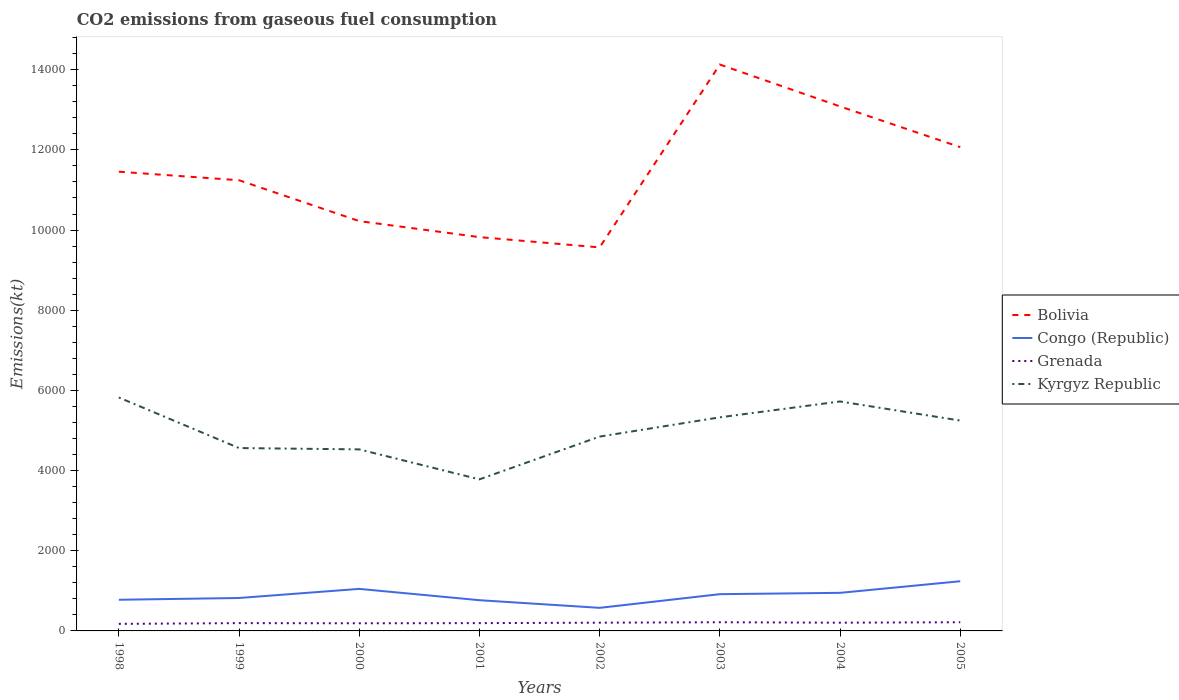How many different coloured lines are there?
Offer a terse response. 4. Does the line corresponding to Congo (Republic) intersect with the line corresponding to Kyrgyz Republic?
Your response must be concise. No. Is the number of lines equal to the number of legend labels?
Provide a short and direct response. Yes. Across all years, what is the maximum amount of CO2 emitted in Grenada?
Give a very brief answer. 176.02. In which year was the amount of CO2 emitted in Congo (Republic) maximum?
Keep it short and to the point. 2002. What is the difference between the highest and the second highest amount of CO2 emitted in Congo (Republic)?
Your response must be concise. 663.73. Is the amount of CO2 emitted in Congo (Republic) strictly greater than the amount of CO2 emitted in Kyrgyz Republic over the years?
Provide a short and direct response. Yes. What is the difference between two consecutive major ticks on the Y-axis?
Your answer should be compact. 2000. Are the values on the major ticks of Y-axis written in scientific E-notation?
Keep it short and to the point. No. How many legend labels are there?
Give a very brief answer. 4. What is the title of the graph?
Offer a terse response. CO2 emissions from gaseous fuel consumption. What is the label or title of the X-axis?
Your answer should be compact. Years. What is the label or title of the Y-axis?
Your response must be concise. Emissions(kt). What is the Emissions(kt) of Bolivia in 1998?
Ensure brevity in your answer.  1.15e+04. What is the Emissions(kt) in Congo (Republic) in 1998?
Offer a terse response. 777.4. What is the Emissions(kt) in Grenada in 1998?
Your answer should be compact. 176.02. What is the Emissions(kt) of Kyrgyz Republic in 1998?
Give a very brief answer. 5823.2. What is the Emissions(kt) of Bolivia in 1999?
Your response must be concise. 1.12e+04. What is the Emissions(kt) of Congo (Republic) in 1999?
Provide a succinct answer. 821.41. What is the Emissions(kt) of Grenada in 1999?
Offer a very short reply. 194.35. What is the Emissions(kt) in Kyrgyz Republic in 1999?
Ensure brevity in your answer.  4561.75. What is the Emissions(kt) of Bolivia in 2000?
Keep it short and to the point. 1.02e+04. What is the Emissions(kt) of Congo (Republic) in 2000?
Offer a terse response. 1048.76. What is the Emissions(kt) in Grenada in 2000?
Your response must be concise. 190.68. What is the Emissions(kt) of Kyrgyz Republic in 2000?
Provide a succinct answer. 4528.74. What is the Emissions(kt) of Bolivia in 2001?
Your answer should be compact. 9823.89. What is the Emissions(kt) in Congo (Republic) in 2001?
Offer a terse response. 766.4. What is the Emissions(kt) of Grenada in 2001?
Offer a terse response. 194.35. What is the Emissions(kt) in Kyrgyz Republic in 2001?
Give a very brief answer. 3780.68. What is the Emissions(kt) of Bolivia in 2002?
Provide a short and direct response. 9567.2. What is the Emissions(kt) in Congo (Republic) in 2002?
Keep it short and to the point. 575.72. What is the Emissions(kt) of Grenada in 2002?
Keep it short and to the point. 205.35. What is the Emissions(kt) of Kyrgyz Republic in 2002?
Make the answer very short. 4847.77. What is the Emissions(kt) of Bolivia in 2003?
Your answer should be compact. 1.41e+04. What is the Emissions(kt) of Congo (Republic) in 2003?
Provide a succinct answer. 916.75. What is the Emissions(kt) of Grenada in 2003?
Keep it short and to the point. 216.35. What is the Emissions(kt) of Kyrgyz Republic in 2003?
Offer a very short reply. 5328.15. What is the Emissions(kt) in Bolivia in 2004?
Offer a terse response. 1.31e+04. What is the Emissions(kt) in Congo (Republic) in 2004?
Ensure brevity in your answer.  949.75. What is the Emissions(kt) in Grenada in 2004?
Offer a very short reply. 205.35. What is the Emissions(kt) of Kyrgyz Republic in 2004?
Ensure brevity in your answer.  5724.19. What is the Emissions(kt) in Bolivia in 2005?
Keep it short and to the point. 1.21e+04. What is the Emissions(kt) in Congo (Republic) in 2005?
Keep it short and to the point. 1239.45. What is the Emissions(kt) of Grenada in 2005?
Provide a succinct answer. 216.35. What is the Emissions(kt) in Kyrgyz Republic in 2005?
Provide a succinct answer. 5247.48. Across all years, what is the maximum Emissions(kt) of Bolivia?
Provide a short and direct response. 1.41e+04. Across all years, what is the maximum Emissions(kt) in Congo (Republic)?
Offer a terse response. 1239.45. Across all years, what is the maximum Emissions(kt) in Grenada?
Offer a very short reply. 216.35. Across all years, what is the maximum Emissions(kt) in Kyrgyz Republic?
Give a very brief answer. 5823.2. Across all years, what is the minimum Emissions(kt) in Bolivia?
Your answer should be very brief. 9567.2. Across all years, what is the minimum Emissions(kt) in Congo (Republic)?
Give a very brief answer. 575.72. Across all years, what is the minimum Emissions(kt) in Grenada?
Keep it short and to the point. 176.02. Across all years, what is the minimum Emissions(kt) of Kyrgyz Republic?
Make the answer very short. 3780.68. What is the total Emissions(kt) in Bolivia in the graph?
Your answer should be very brief. 9.16e+04. What is the total Emissions(kt) of Congo (Republic) in the graph?
Keep it short and to the point. 7095.65. What is the total Emissions(kt) in Grenada in the graph?
Your response must be concise. 1598.81. What is the total Emissions(kt) in Kyrgyz Republic in the graph?
Offer a terse response. 3.98e+04. What is the difference between the Emissions(kt) of Bolivia in 1998 and that in 1999?
Keep it short and to the point. 212.69. What is the difference between the Emissions(kt) of Congo (Republic) in 1998 and that in 1999?
Provide a short and direct response. -44. What is the difference between the Emissions(kt) of Grenada in 1998 and that in 1999?
Make the answer very short. -18.34. What is the difference between the Emissions(kt) of Kyrgyz Republic in 1998 and that in 1999?
Keep it short and to the point. 1261.45. What is the difference between the Emissions(kt) in Bolivia in 1998 and that in 2000?
Your answer should be very brief. 1232.11. What is the difference between the Emissions(kt) in Congo (Republic) in 1998 and that in 2000?
Your answer should be compact. -271.36. What is the difference between the Emissions(kt) in Grenada in 1998 and that in 2000?
Offer a very short reply. -14.67. What is the difference between the Emissions(kt) of Kyrgyz Republic in 1998 and that in 2000?
Your answer should be very brief. 1294.45. What is the difference between the Emissions(kt) in Bolivia in 1998 and that in 2001?
Make the answer very short. 1631.82. What is the difference between the Emissions(kt) in Congo (Republic) in 1998 and that in 2001?
Your response must be concise. 11. What is the difference between the Emissions(kt) in Grenada in 1998 and that in 2001?
Make the answer very short. -18.34. What is the difference between the Emissions(kt) in Kyrgyz Republic in 1998 and that in 2001?
Make the answer very short. 2042.52. What is the difference between the Emissions(kt) in Bolivia in 1998 and that in 2002?
Offer a terse response. 1888.51. What is the difference between the Emissions(kt) of Congo (Republic) in 1998 and that in 2002?
Keep it short and to the point. 201.69. What is the difference between the Emissions(kt) of Grenada in 1998 and that in 2002?
Give a very brief answer. -29.34. What is the difference between the Emissions(kt) in Kyrgyz Republic in 1998 and that in 2002?
Give a very brief answer. 975.42. What is the difference between the Emissions(kt) in Bolivia in 1998 and that in 2003?
Provide a succinct answer. -2673.24. What is the difference between the Emissions(kt) of Congo (Republic) in 1998 and that in 2003?
Your answer should be compact. -139.35. What is the difference between the Emissions(kt) in Grenada in 1998 and that in 2003?
Provide a succinct answer. -40.34. What is the difference between the Emissions(kt) of Kyrgyz Republic in 1998 and that in 2003?
Ensure brevity in your answer.  495.05. What is the difference between the Emissions(kt) of Bolivia in 1998 and that in 2004?
Make the answer very short. -1628.15. What is the difference between the Emissions(kt) of Congo (Republic) in 1998 and that in 2004?
Provide a succinct answer. -172.35. What is the difference between the Emissions(kt) in Grenada in 1998 and that in 2004?
Give a very brief answer. -29.34. What is the difference between the Emissions(kt) in Kyrgyz Republic in 1998 and that in 2004?
Make the answer very short. 99.01. What is the difference between the Emissions(kt) in Bolivia in 1998 and that in 2005?
Offer a very short reply. -612.39. What is the difference between the Emissions(kt) in Congo (Republic) in 1998 and that in 2005?
Your response must be concise. -462.04. What is the difference between the Emissions(kt) in Grenada in 1998 and that in 2005?
Your answer should be compact. -40.34. What is the difference between the Emissions(kt) in Kyrgyz Republic in 1998 and that in 2005?
Offer a very short reply. 575.72. What is the difference between the Emissions(kt) of Bolivia in 1999 and that in 2000?
Provide a short and direct response. 1019.43. What is the difference between the Emissions(kt) in Congo (Republic) in 1999 and that in 2000?
Provide a succinct answer. -227.35. What is the difference between the Emissions(kt) in Grenada in 1999 and that in 2000?
Your response must be concise. 3.67. What is the difference between the Emissions(kt) of Kyrgyz Republic in 1999 and that in 2000?
Your answer should be very brief. 33. What is the difference between the Emissions(kt) of Bolivia in 1999 and that in 2001?
Make the answer very short. 1419.13. What is the difference between the Emissions(kt) of Congo (Republic) in 1999 and that in 2001?
Offer a terse response. 55.01. What is the difference between the Emissions(kt) in Grenada in 1999 and that in 2001?
Give a very brief answer. 0. What is the difference between the Emissions(kt) of Kyrgyz Republic in 1999 and that in 2001?
Your answer should be very brief. 781.07. What is the difference between the Emissions(kt) of Bolivia in 1999 and that in 2002?
Your answer should be compact. 1675.82. What is the difference between the Emissions(kt) of Congo (Republic) in 1999 and that in 2002?
Keep it short and to the point. 245.69. What is the difference between the Emissions(kt) of Grenada in 1999 and that in 2002?
Ensure brevity in your answer.  -11. What is the difference between the Emissions(kt) of Kyrgyz Republic in 1999 and that in 2002?
Give a very brief answer. -286.03. What is the difference between the Emissions(kt) in Bolivia in 1999 and that in 2003?
Provide a short and direct response. -2885.93. What is the difference between the Emissions(kt) in Congo (Republic) in 1999 and that in 2003?
Make the answer very short. -95.34. What is the difference between the Emissions(kt) in Grenada in 1999 and that in 2003?
Provide a succinct answer. -22. What is the difference between the Emissions(kt) of Kyrgyz Republic in 1999 and that in 2003?
Provide a short and direct response. -766.4. What is the difference between the Emissions(kt) of Bolivia in 1999 and that in 2004?
Make the answer very short. -1840.83. What is the difference between the Emissions(kt) of Congo (Republic) in 1999 and that in 2004?
Ensure brevity in your answer.  -128.34. What is the difference between the Emissions(kt) in Grenada in 1999 and that in 2004?
Offer a very short reply. -11. What is the difference between the Emissions(kt) in Kyrgyz Republic in 1999 and that in 2004?
Give a very brief answer. -1162.44. What is the difference between the Emissions(kt) in Bolivia in 1999 and that in 2005?
Provide a succinct answer. -825.08. What is the difference between the Emissions(kt) in Congo (Republic) in 1999 and that in 2005?
Make the answer very short. -418.04. What is the difference between the Emissions(kt) of Grenada in 1999 and that in 2005?
Your answer should be very brief. -22. What is the difference between the Emissions(kt) in Kyrgyz Republic in 1999 and that in 2005?
Make the answer very short. -685.73. What is the difference between the Emissions(kt) in Bolivia in 2000 and that in 2001?
Keep it short and to the point. 399.7. What is the difference between the Emissions(kt) of Congo (Republic) in 2000 and that in 2001?
Your answer should be very brief. 282.36. What is the difference between the Emissions(kt) in Grenada in 2000 and that in 2001?
Offer a terse response. -3.67. What is the difference between the Emissions(kt) in Kyrgyz Republic in 2000 and that in 2001?
Your response must be concise. 748.07. What is the difference between the Emissions(kt) of Bolivia in 2000 and that in 2002?
Make the answer very short. 656.39. What is the difference between the Emissions(kt) of Congo (Republic) in 2000 and that in 2002?
Keep it short and to the point. 473.04. What is the difference between the Emissions(kt) of Grenada in 2000 and that in 2002?
Offer a very short reply. -14.67. What is the difference between the Emissions(kt) in Kyrgyz Republic in 2000 and that in 2002?
Ensure brevity in your answer.  -319.03. What is the difference between the Emissions(kt) in Bolivia in 2000 and that in 2003?
Keep it short and to the point. -3905.36. What is the difference between the Emissions(kt) in Congo (Republic) in 2000 and that in 2003?
Keep it short and to the point. 132.01. What is the difference between the Emissions(kt) in Grenada in 2000 and that in 2003?
Your response must be concise. -25.67. What is the difference between the Emissions(kt) of Kyrgyz Republic in 2000 and that in 2003?
Provide a succinct answer. -799.41. What is the difference between the Emissions(kt) in Bolivia in 2000 and that in 2004?
Your answer should be very brief. -2860.26. What is the difference between the Emissions(kt) in Congo (Republic) in 2000 and that in 2004?
Offer a terse response. 99.01. What is the difference between the Emissions(kt) in Grenada in 2000 and that in 2004?
Offer a terse response. -14.67. What is the difference between the Emissions(kt) in Kyrgyz Republic in 2000 and that in 2004?
Ensure brevity in your answer.  -1195.44. What is the difference between the Emissions(kt) of Bolivia in 2000 and that in 2005?
Provide a short and direct response. -1844.5. What is the difference between the Emissions(kt) in Congo (Republic) in 2000 and that in 2005?
Give a very brief answer. -190.68. What is the difference between the Emissions(kt) in Grenada in 2000 and that in 2005?
Provide a succinct answer. -25.67. What is the difference between the Emissions(kt) in Kyrgyz Republic in 2000 and that in 2005?
Offer a terse response. -718.73. What is the difference between the Emissions(kt) in Bolivia in 2001 and that in 2002?
Provide a short and direct response. 256.69. What is the difference between the Emissions(kt) of Congo (Republic) in 2001 and that in 2002?
Give a very brief answer. 190.68. What is the difference between the Emissions(kt) in Grenada in 2001 and that in 2002?
Ensure brevity in your answer.  -11. What is the difference between the Emissions(kt) of Kyrgyz Republic in 2001 and that in 2002?
Provide a short and direct response. -1067.1. What is the difference between the Emissions(kt) of Bolivia in 2001 and that in 2003?
Your answer should be very brief. -4305.06. What is the difference between the Emissions(kt) of Congo (Republic) in 2001 and that in 2003?
Keep it short and to the point. -150.35. What is the difference between the Emissions(kt) of Grenada in 2001 and that in 2003?
Your answer should be compact. -22. What is the difference between the Emissions(kt) of Kyrgyz Republic in 2001 and that in 2003?
Provide a succinct answer. -1547.47. What is the difference between the Emissions(kt) of Bolivia in 2001 and that in 2004?
Your answer should be compact. -3259.96. What is the difference between the Emissions(kt) in Congo (Republic) in 2001 and that in 2004?
Provide a succinct answer. -183.35. What is the difference between the Emissions(kt) of Grenada in 2001 and that in 2004?
Give a very brief answer. -11. What is the difference between the Emissions(kt) of Kyrgyz Republic in 2001 and that in 2004?
Give a very brief answer. -1943.51. What is the difference between the Emissions(kt) in Bolivia in 2001 and that in 2005?
Make the answer very short. -2244.2. What is the difference between the Emissions(kt) of Congo (Republic) in 2001 and that in 2005?
Your answer should be very brief. -473.04. What is the difference between the Emissions(kt) of Grenada in 2001 and that in 2005?
Offer a terse response. -22. What is the difference between the Emissions(kt) in Kyrgyz Republic in 2001 and that in 2005?
Give a very brief answer. -1466.8. What is the difference between the Emissions(kt) of Bolivia in 2002 and that in 2003?
Your answer should be compact. -4561.75. What is the difference between the Emissions(kt) of Congo (Republic) in 2002 and that in 2003?
Make the answer very short. -341.03. What is the difference between the Emissions(kt) in Grenada in 2002 and that in 2003?
Your answer should be compact. -11. What is the difference between the Emissions(kt) of Kyrgyz Republic in 2002 and that in 2003?
Provide a succinct answer. -480.38. What is the difference between the Emissions(kt) in Bolivia in 2002 and that in 2004?
Offer a very short reply. -3516.65. What is the difference between the Emissions(kt) in Congo (Republic) in 2002 and that in 2004?
Provide a short and direct response. -374.03. What is the difference between the Emissions(kt) in Kyrgyz Republic in 2002 and that in 2004?
Offer a terse response. -876.41. What is the difference between the Emissions(kt) of Bolivia in 2002 and that in 2005?
Keep it short and to the point. -2500.89. What is the difference between the Emissions(kt) in Congo (Republic) in 2002 and that in 2005?
Your answer should be compact. -663.73. What is the difference between the Emissions(kt) in Grenada in 2002 and that in 2005?
Provide a succinct answer. -11. What is the difference between the Emissions(kt) of Kyrgyz Republic in 2002 and that in 2005?
Your answer should be very brief. -399.7. What is the difference between the Emissions(kt) in Bolivia in 2003 and that in 2004?
Your answer should be compact. 1045.1. What is the difference between the Emissions(kt) of Congo (Republic) in 2003 and that in 2004?
Provide a succinct answer. -33. What is the difference between the Emissions(kt) of Grenada in 2003 and that in 2004?
Offer a very short reply. 11. What is the difference between the Emissions(kt) in Kyrgyz Republic in 2003 and that in 2004?
Offer a very short reply. -396.04. What is the difference between the Emissions(kt) of Bolivia in 2003 and that in 2005?
Provide a succinct answer. 2060.85. What is the difference between the Emissions(kt) of Congo (Republic) in 2003 and that in 2005?
Your response must be concise. -322.7. What is the difference between the Emissions(kt) of Grenada in 2003 and that in 2005?
Your response must be concise. 0. What is the difference between the Emissions(kt) of Kyrgyz Republic in 2003 and that in 2005?
Keep it short and to the point. 80.67. What is the difference between the Emissions(kt) in Bolivia in 2004 and that in 2005?
Give a very brief answer. 1015.76. What is the difference between the Emissions(kt) of Congo (Republic) in 2004 and that in 2005?
Your answer should be compact. -289.69. What is the difference between the Emissions(kt) of Grenada in 2004 and that in 2005?
Keep it short and to the point. -11. What is the difference between the Emissions(kt) of Kyrgyz Republic in 2004 and that in 2005?
Make the answer very short. 476.71. What is the difference between the Emissions(kt) in Bolivia in 1998 and the Emissions(kt) in Congo (Republic) in 1999?
Provide a succinct answer. 1.06e+04. What is the difference between the Emissions(kt) in Bolivia in 1998 and the Emissions(kt) in Grenada in 1999?
Give a very brief answer. 1.13e+04. What is the difference between the Emissions(kt) in Bolivia in 1998 and the Emissions(kt) in Kyrgyz Republic in 1999?
Your answer should be compact. 6893.96. What is the difference between the Emissions(kt) of Congo (Republic) in 1998 and the Emissions(kt) of Grenada in 1999?
Your answer should be very brief. 583.05. What is the difference between the Emissions(kt) in Congo (Republic) in 1998 and the Emissions(kt) in Kyrgyz Republic in 1999?
Offer a terse response. -3784.34. What is the difference between the Emissions(kt) of Grenada in 1998 and the Emissions(kt) of Kyrgyz Republic in 1999?
Keep it short and to the point. -4385.73. What is the difference between the Emissions(kt) in Bolivia in 1998 and the Emissions(kt) in Congo (Republic) in 2000?
Offer a very short reply. 1.04e+04. What is the difference between the Emissions(kt) of Bolivia in 1998 and the Emissions(kt) of Grenada in 2000?
Offer a terse response. 1.13e+04. What is the difference between the Emissions(kt) in Bolivia in 1998 and the Emissions(kt) in Kyrgyz Republic in 2000?
Ensure brevity in your answer.  6926.96. What is the difference between the Emissions(kt) in Congo (Republic) in 1998 and the Emissions(kt) in Grenada in 2000?
Give a very brief answer. 586.72. What is the difference between the Emissions(kt) of Congo (Republic) in 1998 and the Emissions(kt) of Kyrgyz Republic in 2000?
Make the answer very short. -3751.34. What is the difference between the Emissions(kt) of Grenada in 1998 and the Emissions(kt) of Kyrgyz Republic in 2000?
Make the answer very short. -4352.73. What is the difference between the Emissions(kt) of Bolivia in 1998 and the Emissions(kt) of Congo (Republic) in 2001?
Offer a terse response. 1.07e+04. What is the difference between the Emissions(kt) of Bolivia in 1998 and the Emissions(kt) of Grenada in 2001?
Provide a succinct answer. 1.13e+04. What is the difference between the Emissions(kt) of Bolivia in 1998 and the Emissions(kt) of Kyrgyz Republic in 2001?
Your answer should be very brief. 7675.03. What is the difference between the Emissions(kt) in Congo (Republic) in 1998 and the Emissions(kt) in Grenada in 2001?
Provide a short and direct response. 583.05. What is the difference between the Emissions(kt) of Congo (Republic) in 1998 and the Emissions(kt) of Kyrgyz Republic in 2001?
Offer a very short reply. -3003.27. What is the difference between the Emissions(kt) of Grenada in 1998 and the Emissions(kt) of Kyrgyz Republic in 2001?
Keep it short and to the point. -3604.66. What is the difference between the Emissions(kt) of Bolivia in 1998 and the Emissions(kt) of Congo (Republic) in 2002?
Your answer should be compact. 1.09e+04. What is the difference between the Emissions(kt) of Bolivia in 1998 and the Emissions(kt) of Grenada in 2002?
Ensure brevity in your answer.  1.13e+04. What is the difference between the Emissions(kt) of Bolivia in 1998 and the Emissions(kt) of Kyrgyz Republic in 2002?
Give a very brief answer. 6607.93. What is the difference between the Emissions(kt) of Congo (Republic) in 1998 and the Emissions(kt) of Grenada in 2002?
Make the answer very short. 572.05. What is the difference between the Emissions(kt) in Congo (Republic) in 1998 and the Emissions(kt) in Kyrgyz Republic in 2002?
Your answer should be compact. -4070.37. What is the difference between the Emissions(kt) of Grenada in 1998 and the Emissions(kt) of Kyrgyz Republic in 2002?
Make the answer very short. -4671.76. What is the difference between the Emissions(kt) of Bolivia in 1998 and the Emissions(kt) of Congo (Republic) in 2003?
Your answer should be very brief. 1.05e+04. What is the difference between the Emissions(kt) of Bolivia in 1998 and the Emissions(kt) of Grenada in 2003?
Provide a short and direct response. 1.12e+04. What is the difference between the Emissions(kt) of Bolivia in 1998 and the Emissions(kt) of Kyrgyz Republic in 2003?
Give a very brief answer. 6127.56. What is the difference between the Emissions(kt) of Congo (Republic) in 1998 and the Emissions(kt) of Grenada in 2003?
Give a very brief answer. 561.05. What is the difference between the Emissions(kt) of Congo (Republic) in 1998 and the Emissions(kt) of Kyrgyz Republic in 2003?
Your answer should be very brief. -4550.75. What is the difference between the Emissions(kt) of Grenada in 1998 and the Emissions(kt) of Kyrgyz Republic in 2003?
Provide a short and direct response. -5152.14. What is the difference between the Emissions(kt) in Bolivia in 1998 and the Emissions(kt) in Congo (Republic) in 2004?
Your answer should be very brief. 1.05e+04. What is the difference between the Emissions(kt) of Bolivia in 1998 and the Emissions(kt) of Grenada in 2004?
Offer a terse response. 1.13e+04. What is the difference between the Emissions(kt) in Bolivia in 1998 and the Emissions(kt) in Kyrgyz Republic in 2004?
Provide a short and direct response. 5731.52. What is the difference between the Emissions(kt) in Congo (Republic) in 1998 and the Emissions(kt) in Grenada in 2004?
Give a very brief answer. 572.05. What is the difference between the Emissions(kt) in Congo (Republic) in 1998 and the Emissions(kt) in Kyrgyz Republic in 2004?
Provide a short and direct response. -4946.78. What is the difference between the Emissions(kt) of Grenada in 1998 and the Emissions(kt) of Kyrgyz Republic in 2004?
Make the answer very short. -5548.17. What is the difference between the Emissions(kt) of Bolivia in 1998 and the Emissions(kt) of Congo (Republic) in 2005?
Your answer should be compact. 1.02e+04. What is the difference between the Emissions(kt) of Bolivia in 1998 and the Emissions(kt) of Grenada in 2005?
Ensure brevity in your answer.  1.12e+04. What is the difference between the Emissions(kt) of Bolivia in 1998 and the Emissions(kt) of Kyrgyz Republic in 2005?
Your answer should be very brief. 6208.23. What is the difference between the Emissions(kt) in Congo (Republic) in 1998 and the Emissions(kt) in Grenada in 2005?
Your answer should be compact. 561.05. What is the difference between the Emissions(kt) of Congo (Republic) in 1998 and the Emissions(kt) of Kyrgyz Republic in 2005?
Ensure brevity in your answer.  -4470.07. What is the difference between the Emissions(kt) of Grenada in 1998 and the Emissions(kt) of Kyrgyz Republic in 2005?
Give a very brief answer. -5071.46. What is the difference between the Emissions(kt) in Bolivia in 1999 and the Emissions(kt) in Congo (Republic) in 2000?
Give a very brief answer. 1.02e+04. What is the difference between the Emissions(kt) of Bolivia in 1999 and the Emissions(kt) of Grenada in 2000?
Your answer should be very brief. 1.11e+04. What is the difference between the Emissions(kt) of Bolivia in 1999 and the Emissions(kt) of Kyrgyz Republic in 2000?
Your response must be concise. 6714.28. What is the difference between the Emissions(kt) of Congo (Republic) in 1999 and the Emissions(kt) of Grenada in 2000?
Ensure brevity in your answer.  630.72. What is the difference between the Emissions(kt) in Congo (Republic) in 1999 and the Emissions(kt) in Kyrgyz Republic in 2000?
Offer a very short reply. -3707.34. What is the difference between the Emissions(kt) in Grenada in 1999 and the Emissions(kt) in Kyrgyz Republic in 2000?
Keep it short and to the point. -4334.39. What is the difference between the Emissions(kt) in Bolivia in 1999 and the Emissions(kt) in Congo (Republic) in 2001?
Offer a very short reply. 1.05e+04. What is the difference between the Emissions(kt) of Bolivia in 1999 and the Emissions(kt) of Grenada in 2001?
Provide a succinct answer. 1.10e+04. What is the difference between the Emissions(kt) in Bolivia in 1999 and the Emissions(kt) in Kyrgyz Republic in 2001?
Keep it short and to the point. 7462.35. What is the difference between the Emissions(kt) of Congo (Republic) in 1999 and the Emissions(kt) of Grenada in 2001?
Your answer should be very brief. 627.06. What is the difference between the Emissions(kt) of Congo (Republic) in 1999 and the Emissions(kt) of Kyrgyz Republic in 2001?
Keep it short and to the point. -2959.27. What is the difference between the Emissions(kt) of Grenada in 1999 and the Emissions(kt) of Kyrgyz Republic in 2001?
Provide a short and direct response. -3586.33. What is the difference between the Emissions(kt) in Bolivia in 1999 and the Emissions(kt) in Congo (Republic) in 2002?
Your answer should be compact. 1.07e+04. What is the difference between the Emissions(kt) of Bolivia in 1999 and the Emissions(kt) of Grenada in 2002?
Offer a very short reply. 1.10e+04. What is the difference between the Emissions(kt) of Bolivia in 1999 and the Emissions(kt) of Kyrgyz Republic in 2002?
Your answer should be compact. 6395.25. What is the difference between the Emissions(kt) in Congo (Republic) in 1999 and the Emissions(kt) in Grenada in 2002?
Your response must be concise. 616.06. What is the difference between the Emissions(kt) of Congo (Republic) in 1999 and the Emissions(kt) of Kyrgyz Republic in 2002?
Your answer should be very brief. -4026.37. What is the difference between the Emissions(kt) of Grenada in 1999 and the Emissions(kt) of Kyrgyz Republic in 2002?
Make the answer very short. -4653.42. What is the difference between the Emissions(kt) of Bolivia in 1999 and the Emissions(kt) of Congo (Republic) in 2003?
Provide a succinct answer. 1.03e+04. What is the difference between the Emissions(kt) in Bolivia in 1999 and the Emissions(kt) in Grenada in 2003?
Make the answer very short. 1.10e+04. What is the difference between the Emissions(kt) in Bolivia in 1999 and the Emissions(kt) in Kyrgyz Republic in 2003?
Your answer should be very brief. 5914.87. What is the difference between the Emissions(kt) of Congo (Republic) in 1999 and the Emissions(kt) of Grenada in 2003?
Provide a short and direct response. 605.05. What is the difference between the Emissions(kt) of Congo (Republic) in 1999 and the Emissions(kt) of Kyrgyz Republic in 2003?
Make the answer very short. -4506.74. What is the difference between the Emissions(kt) in Grenada in 1999 and the Emissions(kt) in Kyrgyz Republic in 2003?
Offer a very short reply. -5133.8. What is the difference between the Emissions(kt) of Bolivia in 1999 and the Emissions(kt) of Congo (Republic) in 2004?
Offer a very short reply. 1.03e+04. What is the difference between the Emissions(kt) in Bolivia in 1999 and the Emissions(kt) in Grenada in 2004?
Make the answer very short. 1.10e+04. What is the difference between the Emissions(kt) of Bolivia in 1999 and the Emissions(kt) of Kyrgyz Republic in 2004?
Keep it short and to the point. 5518.84. What is the difference between the Emissions(kt) in Congo (Republic) in 1999 and the Emissions(kt) in Grenada in 2004?
Your response must be concise. 616.06. What is the difference between the Emissions(kt) of Congo (Republic) in 1999 and the Emissions(kt) of Kyrgyz Republic in 2004?
Your answer should be compact. -4902.78. What is the difference between the Emissions(kt) in Grenada in 1999 and the Emissions(kt) in Kyrgyz Republic in 2004?
Provide a succinct answer. -5529.84. What is the difference between the Emissions(kt) of Bolivia in 1999 and the Emissions(kt) of Congo (Republic) in 2005?
Make the answer very short. 1.00e+04. What is the difference between the Emissions(kt) of Bolivia in 1999 and the Emissions(kt) of Grenada in 2005?
Your answer should be very brief. 1.10e+04. What is the difference between the Emissions(kt) of Bolivia in 1999 and the Emissions(kt) of Kyrgyz Republic in 2005?
Provide a short and direct response. 5995.55. What is the difference between the Emissions(kt) in Congo (Republic) in 1999 and the Emissions(kt) in Grenada in 2005?
Provide a succinct answer. 605.05. What is the difference between the Emissions(kt) in Congo (Republic) in 1999 and the Emissions(kt) in Kyrgyz Republic in 2005?
Your answer should be compact. -4426.07. What is the difference between the Emissions(kt) of Grenada in 1999 and the Emissions(kt) of Kyrgyz Republic in 2005?
Provide a short and direct response. -5053.13. What is the difference between the Emissions(kt) in Bolivia in 2000 and the Emissions(kt) in Congo (Republic) in 2001?
Your answer should be very brief. 9457.19. What is the difference between the Emissions(kt) of Bolivia in 2000 and the Emissions(kt) of Grenada in 2001?
Give a very brief answer. 1.00e+04. What is the difference between the Emissions(kt) in Bolivia in 2000 and the Emissions(kt) in Kyrgyz Republic in 2001?
Keep it short and to the point. 6442.92. What is the difference between the Emissions(kt) of Congo (Republic) in 2000 and the Emissions(kt) of Grenada in 2001?
Your answer should be very brief. 854.41. What is the difference between the Emissions(kt) of Congo (Republic) in 2000 and the Emissions(kt) of Kyrgyz Republic in 2001?
Your response must be concise. -2731.91. What is the difference between the Emissions(kt) in Grenada in 2000 and the Emissions(kt) in Kyrgyz Republic in 2001?
Offer a terse response. -3589.99. What is the difference between the Emissions(kt) in Bolivia in 2000 and the Emissions(kt) in Congo (Republic) in 2002?
Your answer should be compact. 9647.88. What is the difference between the Emissions(kt) of Bolivia in 2000 and the Emissions(kt) of Grenada in 2002?
Provide a succinct answer. 1.00e+04. What is the difference between the Emissions(kt) in Bolivia in 2000 and the Emissions(kt) in Kyrgyz Republic in 2002?
Your response must be concise. 5375.82. What is the difference between the Emissions(kt) in Congo (Republic) in 2000 and the Emissions(kt) in Grenada in 2002?
Provide a short and direct response. 843.41. What is the difference between the Emissions(kt) of Congo (Republic) in 2000 and the Emissions(kt) of Kyrgyz Republic in 2002?
Your response must be concise. -3799.01. What is the difference between the Emissions(kt) of Grenada in 2000 and the Emissions(kt) of Kyrgyz Republic in 2002?
Your answer should be compact. -4657.09. What is the difference between the Emissions(kt) of Bolivia in 2000 and the Emissions(kt) of Congo (Republic) in 2003?
Provide a succinct answer. 9306.85. What is the difference between the Emissions(kt) of Bolivia in 2000 and the Emissions(kt) of Grenada in 2003?
Keep it short and to the point. 1.00e+04. What is the difference between the Emissions(kt) in Bolivia in 2000 and the Emissions(kt) in Kyrgyz Republic in 2003?
Your answer should be compact. 4895.44. What is the difference between the Emissions(kt) in Congo (Republic) in 2000 and the Emissions(kt) in Grenada in 2003?
Give a very brief answer. 832.41. What is the difference between the Emissions(kt) of Congo (Republic) in 2000 and the Emissions(kt) of Kyrgyz Republic in 2003?
Provide a short and direct response. -4279.39. What is the difference between the Emissions(kt) in Grenada in 2000 and the Emissions(kt) in Kyrgyz Republic in 2003?
Give a very brief answer. -5137.47. What is the difference between the Emissions(kt) of Bolivia in 2000 and the Emissions(kt) of Congo (Republic) in 2004?
Keep it short and to the point. 9273.84. What is the difference between the Emissions(kt) of Bolivia in 2000 and the Emissions(kt) of Grenada in 2004?
Offer a terse response. 1.00e+04. What is the difference between the Emissions(kt) of Bolivia in 2000 and the Emissions(kt) of Kyrgyz Republic in 2004?
Make the answer very short. 4499.41. What is the difference between the Emissions(kt) of Congo (Republic) in 2000 and the Emissions(kt) of Grenada in 2004?
Keep it short and to the point. 843.41. What is the difference between the Emissions(kt) in Congo (Republic) in 2000 and the Emissions(kt) in Kyrgyz Republic in 2004?
Offer a very short reply. -4675.43. What is the difference between the Emissions(kt) of Grenada in 2000 and the Emissions(kt) of Kyrgyz Republic in 2004?
Your answer should be very brief. -5533.5. What is the difference between the Emissions(kt) of Bolivia in 2000 and the Emissions(kt) of Congo (Republic) in 2005?
Ensure brevity in your answer.  8984.15. What is the difference between the Emissions(kt) of Bolivia in 2000 and the Emissions(kt) of Grenada in 2005?
Provide a succinct answer. 1.00e+04. What is the difference between the Emissions(kt) of Bolivia in 2000 and the Emissions(kt) of Kyrgyz Republic in 2005?
Your answer should be very brief. 4976.12. What is the difference between the Emissions(kt) in Congo (Republic) in 2000 and the Emissions(kt) in Grenada in 2005?
Your response must be concise. 832.41. What is the difference between the Emissions(kt) in Congo (Republic) in 2000 and the Emissions(kt) in Kyrgyz Republic in 2005?
Keep it short and to the point. -4198.72. What is the difference between the Emissions(kt) of Grenada in 2000 and the Emissions(kt) of Kyrgyz Republic in 2005?
Provide a short and direct response. -5056.79. What is the difference between the Emissions(kt) in Bolivia in 2001 and the Emissions(kt) in Congo (Republic) in 2002?
Provide a succinct answer. 9248.17. What is the difference between the Emissions(kt) in Bolivia in 2001 and the Emissions(kt) in Grenada in 2002?
Offer a very short reply. 9618.54. What is the difference between the Emissions(kt) in Bolivia in 2001 and the Emissions(kt) in Kyrgyz Republic in 2002?
Give a very brief answer. 4976.12. What is the difference between the Emissions(kt) in Congo (Republic) in 2001 and the Emissions(kt) in Grenada in 2002?
Your response must be concise. 561.05. What is the difference between the Emissions(kt) in Congo (Republic) in 2001 and the Emissions(kt) in Kyrgyz Republic in 2002?
Offer a very short reply. -4081.37. What is the difference between the Emissions(kt) of Grenada in 2001 and the Emissions(kt) of Kyrgyz Republic in 2002?
Make the answer very short. -4653.42. What is the difference between the Emissions(kt) of Bolivia in 2001 and the Emissions(kt) of Congo (Republic) in 2003?
Provide a short and direct response. 8907.14. What is the difference between the Emissions(kt) of Bolivia in 2001 and the Emissions(kt) of Grenada in 2003?
Offer a very short reply. 9607.54. What is the difference between the Emissions(kt) in Bolivia in 2001 and the Emissions(kt) in Kyrgyz Republic in 2003?
Offer a terse response. 4495.74. What is the difference between the Emissions(kt) of Congo (Republic) in 2001 and the Emissions(kt) of Grenada in 2003?
Your answer should be very brief. 550.05. What is the difference between the Emissions(kt) in Congo (Republic) in 2001 and the Emissions(kt) in Kyrgyz Republic in 2003?
Keep it short and to the point. -4561.75. What is the difference between the Emissions(kt) in Grenada in 2001 and the Emissions(kt) in Kyrgyz Republic in 2003?
Offer a terse response. -5133.8. What is the difference between the Emissions(kt) of Bolivia in 2001 and the Emissions(kt) of Congo (Republic) in 2004?
Offer a very short reply. 8874.14. What is the difference between the Emissions(kt) in Bolivia in 2001 and the Emissions(kt) in Grenada in 2004?
Your response must be concise. 9618.54. What is the difference between the Emissions(kt) in Bolivia in 2001 and the Emissions(kt) in Kyrgyz Republic in 2004?
Keep it short and to the point. 4099.71. What is the difference between the Emissions(kt) in Congo (Republic) in 2001 and the Emissions(kt) in Grenada in 2004?
Offer a very short reply. 561.05. What is the difference between the Emissions(kt) of Congo (Republic) in 2001 and the Emissions(kt) of Kyrgyz Republic in 2004?
Ensure brevity in your answer.  -4957.78. What is the difference between the Emissions(kt) in Grenada in 2001 and the Emissions(kt) in Kyrgyz Republic in 2004?
Offer a very short reply. -5529.84. What is the difference between the Emissions(kt) in Bolivia in 2001 and the Emissions(kt) in Congo (Republic) in 2005?
Offer a very short reply. 8584.45. What is the difference between the Emissions(kt) in Bolivia in 2001 and the Emissions(kt) in Grenada in 2005?
Your answer should be compact. 9607.54. What is the difference between the Emissions(kt) of Bolivia in 2001 and the Emissions(kt) of Kyrgyz Republic in 2005?
Your answer should be very brief. 4576.42. What is the difference between the Emissions(kt) in Congo (Republic) in 2001 and the Emissions(kt) in Grenada in 2005?
Offer a very short reply. 550.05. What is the difference between the Emissions(kt) of Congo (Republic) in 2001 and the Emissions(kt) of Kyrgyz Republic in 2005?
Give a very brief answer. -4481.07. What is the difference between the Emissions(kt) of Grenada in 2001 and the Emissions(kt) of Kyrgyz Republic in 2005?
Ensure brevity in your answer.  -5053.13. What is the difference between the Emissions(kt) in Bolivia in 2002 and the Emissions(kt) in Congo (Republic) in 2003?
Offer a terse response. 8650.45. What is the difference between the Emissions(kt) of Bolivia in 2002 and the Emissions(kt) of Grenada in 2003?
Keep it short and to the point. 9350.85. What is the difference between the Emissions(kt) of Bolivia in 2002 and the Emissions(kt) of Kyrgyz Republic in 2003?
Make the answer very short. 4239.05. What is the difference between the Emissions(kt) of Congo (Republic) in 2002 and the Emissions(kt) of Grenada in 2003?
Make the answer very short. 359.37. What is the difference between the Emissions(kt) in Congo (Republic) in 2002 and the Emissions(kt) in Kyrgyz Republic in 2003?
Keep it short and to the point. -4752.43. What is the difference between the Emissions(kt) in Grenada in 2002 and the Emissions(kt) in Kyrgyz Republic in 2003?
Offer a terse response. -5122.8. What is the difference between the Emissions(kt) of Bolivia in 2002 and the Emissions(kt) of Congo (Republic) in 2004?
Your answer should be very brief. 8617.45. What is the difference between the Emissions(kt) in Bolivia in 2002 and the Emissions(kt) in Grenada in 2004?
Your response must be concise. 9361.85. What is the difference between the Emissions(kt) in Bolivia in 2002 and the Emissions(kt) in Kyrgyz Republic in 2004?
Keep it short and to the point. 3843.02. What is the difference between the Emissions(kt) of Congo (Republic) in 2002 and the Emissions(kt) of Grenada in 2004?
Keep it short and to the point. 370.37. What is the difference between the Emissions(kt) in Congo (Republic) in 2002 and the Emissions(kt) in Kyrgyz Republic in 2004?
Keep it short and to the point. -5148.47. What is the difference between the Emissions(kt) in Grenada in 2002 and the Emissions(kt) in Kyrgyz Republic in 2004?
Give a very brief answer. -5518.84. What is the difference between the Emissions(kt) in Bolivia in 2002 and the Emissions(kt) in Congo (Republic) in 2005?
Your response must be concise. 8327.76. What is the difference between the Emissions(kt) of Bolivia in 2002 and the Emissions(kt) of Grenada in 2005?
Your answer should be very brief. 9350.85. What is the difference between the Emissions(kt) in Bolivia in 2002 and the Emissions(kt) in Kyrgyz Republic in 2005?
Offer a very short reply. 4319.73. What is the difference between the Emissions(kt) in Congo (Republic) in 2002 and the Emissions(kt) in Grenada in 2005?
Your response must be concise. 359.37. What is the difference between the Emissions(kt) of Congo (Republic) in 2002 and the Emissions(kt) of Kyrgyz Republic in 2005?
Offer a very short reply. -4671.76. What is the difference between the Emissions(kt) of Grenada in 2002 and the Emissions(kt) of Kyrgyz Republic in 2005?
Provide a short and direct response. -5042.12. What is the difference between the Emissions(kt) of Bolivia in 2003 and the Emissions(kt) of Congo (Republic) in 2004?
Give a very brief answer. 1.32e+04. What is the difference between the Emissions(kt) of Bolivia in 2003 and the Emissions(kt) of Grenada in 2004?
Offer a terse response. 1.39e+04. What is the difference between the Emissions(kt) in Bolivia in 2003 and the Emissions(kt) in Kyrgyz Republic in 2004?
Provide a short and direct response. 8404.76. What is the difference between the Emissions(kt) in Congo (Republic) in 2003 and the Emissions(kt) in Grenada in 2004?
Ensure brevity in your answer.  711.4. What is the difference between the Emissions(kt) of Congo (Republic) in 2003 and the Emissions(kt) of Kyrgyz Republic in 2004?
Provide a short and direct response. -4807.44. What is the difference between the Emissions(kt) in Grenada in 2003 and the Emissions(kt) in Kyrgyz Republic in 2004?
Ensure brevity in your answer.  -5507.83. What is the difference between the Emissions(kt) in Bolivia in 2003 and the Emissions(kt) in Congo (Republic) in 2005?
Your answer should be very brief. 1.29e+04. What is the difference between the Emissions(kt) in Bolivia in 2003 and the Emissions(kt) in Grenada in 2005?
Provide a short and direct response. 1.39e+04. What is the difference between the Emissions(kt) of Bolivia in 2003 and the Emissions(kt) of Kyrgyz Republic in 2005?
Give a very brief answer. 8881.47. What is the difference between the Emissions(kt) of Congo (Republic) in 2003 and the Emissions(kt) of Grenada in 2005?
Your response must be concise. 700.4. What is the difference between the Emissions(kt) in Congo (Republic) in 2003 and the Emissions(kt) in Kyrgyz Republic in 2005?
Keep it short and to the point. -4330.73. What is the difference between the Emissions(kt) of Grenada in 2003 and the Emissions(kt) of Kyrgyz Republic in 2005?
Make the answer very short. -5031.12. What is the difference between the Emissions(kt) in Bolivia in 2004 and the Emissions(kt) in Congo (Republic) in 2005?
Give a very brief answer. 1.18e+04. What is the difference between the Emissions(kt) in Bolivia in 2004 and the Emissions(kt) in Grenada in 2005?
Offer a terse response. 1.29e+04. What is the difference between the Emissions(kt) in Bolivia in 2004 and the Emissions(kt) in Kyrgyz Republic in 2005?
Provide a succinct answer. 7836.38. What is the difference between the Emissions(kt) in Congo (Republic) in 2004 and the Emissions(kt) in Grenada in 2005?
Your response must be concise. 733.4. What is the difference between the Emissions(kt) in Congo (Republic) in 2004 and the Emissions(kt) in Kyrgyz Republic in 2005?
Your answer should be compact. -4297.72. What is the difference between the Emissions(kt) in Grenada in 2004 and the Emissions(kt) in Kyrgyz Republic in 2005?
Your response must be concise. -5042.12. What is the average Emissions(kt) in Bolivia per year?
Make the answer very short. 1.14e+04. What is the average Emissions(kt) in Congo (Republic) per year?
Offer a terse response. 886.96. What is the average Emissions(kt) of Grenada per year?
Your response must be concise. 199.85. What is the average Emissions(kt) of Kyrgyz Republic per year?
Your answer should be compact. 4980.24. In the year 1998, what is the difference between the Emissions(kt) of Bolivia and Emissions(kt) of Congo (Republic)?
Give a very brief answer. 1.07e+04. In the year 1998, what is the difference between the Emissions(kt) in Bolivia and Emissions(kt) in Grenada?
Keep it short and to the point. 1.13e+04. In the year 1998, what is the difference between the Emissions(kt) of Bolivia and Emissions(kt) of Kyrgyz Republic?
Ensure brevity in your answer.  5632.51. In the year 1998, what is the difference between the Emissions(kt) in Congo (Republic) and Emissions(kt) in Grenada?
Provide a succinct answer. 601.39. In the year 1998, what is the difference between the Emissions(kt) in Congo (Republic) and Emissions(kt) in Kyrgyz Republic?
Give a very brief answer. -5045.79. In the year 1998, what is the difference between the Emissions(kt) of Grenada and Emissions(kt) of Kyrgyz Republic?
Offer a very short reply. -5647.18. In the year 1999, what is the difference between the Emissions(kt) of Bolivia and Emissions(kt) of Congo (Republic)?
Your response must be concise. 1.04e+04. In the year 1999, what is the difference between the Emissions(kt) in Bolivia and Emissions(kt) in Grenada?
Keep it short and to the point. 1.10e+04. In the year 1999, what is the difference between the Emissions(kt) of Bolivia and Emissions(kt) of Kyrgyz Republic?
Provide a succinct answer. 6681.27. In the year 1999, what is the difference between the Emissions(kt) in Congo (Republic) and Emissions(kt) in Grenada?
Ensure brevity in your answer.  627.06. In the year 1999, what is the difference between the Emissions(kt) in Congo (Republic) and Emissions(kt) in Kyrgyz Republic?
Make the answer very short. -3740.34. In the year 1999, what is the difference between the Emissions(kt) in Grenada and Emissions(kt) in Kyrgyz Republic?
Your response must be concise. -4367.4. In the year 2000, what is the difference between the Emissions(kt) of Bolivia and Emissions(kt) of Congo (Republic)?
Make the answer very short. 9174.83. In the year 2000, what is the difference between the Emissions(kt) of Bolivia and Emissions(kt) of Grenada?
Offer a terse response. 1.00e+04. In the year 2000, what is the difference between the Emissions(kt) in Bolivia and Emissions(kt) in Kyrgyz Republic?
Your answer should be compact. 5694.85. In the year 2000, what is the difference between the Emissions(kt) in Congo (Republic) and Emissions(kt) in Grenada?
Your answer should be very brief. 858.08. In the year 2000, what is the difference between the Emissions(kt) in Congo (Republic) and Emissions(kt) in Kyrgyz Republic?
Give a very brief answer. -3479.98. In the year 2000, what is the difference between the Emissions(kt) of Grenada and Emissions(kt) of Kyrgyz Republic?
Your response must be concise. -4338.06. In the year 2001, what is the difference between the Emissions(kt) in Bolivia and Emissions(kt) in Congo (Republic)?
Provide a succinct answer. 9057.49. In the year 2001, what is the difference between the Emissions(kt) of Bolivia and Emissions(kt) of Grenada?
Give a very brief answer. 9629.54. In the year 2001, what is the difference between the Emissions(kt) of Bolivia and Emissions(kt) of Kyrgyz Republic?
Keep it short and to the point. 6043.22. In the year 2001, what is the difference between the Emissions(kt) in Congo (Republic) and Emissions(kt) in Grenada?
Ensure brevity in your answer.  572.05. In the year 2001, what is the difference between the Emissions(kt) in Congo (Republic) and Emissions(kt) in Kyrgyz Republic?
Keep it short and to the point. -3014.27. In the year 2001, what is the difference between the Emissions(kt) of Grenada and Emissions(kt) of Kyrgyz Republic?
Ensure brevity in your answer.  -3586.33. In the year 2002, what is the difference between the Emissions(kt) in Bolivia and Emissions(kt) in Congo (Republic)?
Ensure brevity in your answer.  8991.48. In the year 2002, what is the difference between the Emissions(kt) of Bolivia and Emissions(kt) of Grenada?
Offer a terse response. 9361.85. In the year 2002, what is the difference between the Emissions(kt) of Bolivia and Emissions(kt) of Kyrgyz Republic?
Give a very brief answer. 4719.43. In the year 2002, what is the difference between the Emissions(kt) in Congo (Republic) and Emissions(kt) in Grenada?
Give a very brief answer. 370.37. In the year 2002, what is the difference between the Emissions(kt) in Congo (Republic) and Emissions(kt) in Kyrgyz Republic?
Offer a terse response. -4272.06. In the year 2002, what is the difference between the Emissions(kt) in Grenada and Emissions(kt) in Kyrgyz Republic?
Give a very brief answer. -4642.42. In the year 2003, what is the difference between the Emissions(kt) of Bolivia and Emissions(kt) of Congo (Republic)?
Give a very brief answer. 1.32e+04. In the year 2003, what is the difference between the Emissions(kt) in Bolivia and Emissions(kt) in Grenada?
Make the answer very short. 1.39e+04. In the year 2003, what is the difference between the Emissions(kt) of Bolivia and Emissions(kt) of Kyrgyz Republic?
Your answer should be compact. 8800.8. In the year 2003, what is the difference between the Emissions(kt) in Congo (Republic) and Emissions(kt) in Grenada?
Your response must be concise. 700.4. In the year 2003, what is the difference between the Emissions(kt) of Congo (Republic) and Emissions(kt) of Kyrgyz Republic?
Offer a very short reply. -4411.4. In the year 2003, what is the difference between the Emissions(kt) of Grenada and Emissions(kt) of Kyrgyz Republic?
Ensure brevity in your answer.  -5111.8. In the year 2004, what is the difference between the Emissions(kt) in Bolivia and Emissions(kt) in Congo (Republic)?
Give a very brief answer. 1.21e+04. In the year 2004, what is the difference between the Emissions(kt) of Bolivia and Emissions(kt) of Grenada?
Ensure brevity in your answer.  1.29e+04. In the year 2004, what is the difference between the Emissions(kt) in Bolivia and Emissions(kt) in Kyrgyz Republic?
Your response must be concise. 7359.67. In the year 2004, what is the difference between the Emissions(kt) in Congo (Republic) and Emissions(kt) in Grenada?
Make the answer very short. 744.4. In the year 2004, what is the difference between the Emissions(kt) in Congo (Republic) and Emissions(kt) in Kyrgyz Republic?
Keep it short and to the point. -4774.43. In the year 2004, what is the difference between the Emissions(kt) in Grenada and Emissions(kt) in Kyrgyz Republic?
Keep it short and to the point. -5518.84. In the year 2005, what is the difference between the Emissions(kt) of Bolivia and Emissions(kt) of Congo (Republic)?
Make the answer very short. 1.08e+04. In the year 2005, what is the difference between the Emissions(kt) of Bolivia and Emissions(kt) of Grenada?
Provide a short and direct response. 1.19e+04. In the year 2005, what is the difference between the Emissions(kt) of Bolivia and Emissions(kt) of Kyrgyz Republic?
Offer a very short reply. 6820.62. In the year 2005, what is the difference between the Emissions(kt) in Congo (Republic) and Emissions(kt) in Grenada?
Offer a terse response. 1023.09. In the year 2005, what is the difference between the Emissions(kt) in Congo (Republic) and Emissions(kt) in Kyrgyz Republic?
Give a very brief answer. -4008.03. In the year 2005, what is the difference between the Emissions(kt) of Grenada and Emissions(kt) of Kyrgyz Republic?
Your answer should be very brief. -5031.12. What is the ratio of the Emissions(kt) of Bolivia in 1998 to that in 1999?
Your answer should be compact. 1.02. What is the ratio of the Emissions(kt) of Congo (Republic) in 1998 to that in 1999?
Your answer should be compact. 0.95. What is the ratio of the Emissions(kt) in Grenada in 1998 to that in 1999?
Offer a terse response. 0.91. What is the ratio of the Emissions(kt) in Kyrgyz Republic in 1998 to that in 1999?
Your answer should be very brief. 1.28. What is the ratio of the Emissions(kt) of Bolivia in 1998 to that in 2000?
Your answer should be compact. 1.12. What is the ratio of the Emissions(kt) of Congo (Republic) in 1998 to that in 2000?
Provide a short and direct response. 0.74. What is the ratio of the Emissions(kt) of Grenada in 1998 to that in 2000?
Provide a short and direct response. 0.92. What is the ratio of the Emissions(kt) of Kyrgyz Republic in 1998 to that in 2000?
Provide a succinct answer. 1.29. What is the ratio of the Emissions(kt) in Bolivia in 1998 to that in 2001?
Your response must be concise. 1.17. What is the ratio of the Emissions(kt) in Congo (Republic) in 1998 to that in 2001?
Your response must be concise. 1.01. What is the ratio of the Emissions(kt) of Grenada in 1998 to that in 2001?
Offer a terse response. 0.91. What is the ratio of the Emissions(kt) in Kyrgyz Republic in 1998 to that in 2001?
Ensure brevity in your answer.  1.54. What is the ratio of the Emissions(kt) in Bolivia in 1998 to that in 2002?
Your answer should be very brief. 1.2. What is the ratio of the Emissions(kt) in Congo (Republic) in 1998 to that in 2002?
Provide a short and direct response. 1.35. What is the ratio of the Emissions(kt) of Kyrgyz Republic in 1998 to that in 2002?
Make the answer very short. 1.2. What is the ratio of the Emissions(kt) of Bolivia in 1998 to that in 2003?
Offer a very short reply. 0.81. What is the ratio of the Emissions(kt) in Congo (Republic) in 1998 to that in 2003?
Your answer should be very brief. 0.85. What is the ratio of the Emissions(kt) of Grenada in 1998 to that in 2003?
Provide a succinct answer. 0.81. What is the ratio of the Emissions(kt) of Kyrgyz Republic in 1998 to that in 2003?
Offer a very short reply. 1.09. What is the ratio of the Emissions(kt) of Bolivia in 1998 to that in 2004?
Offer a terse response. 0.88. What is the ratio of the Emissions(kt) in Congo (Republic) in 1998 to that in 2004?
Make the answer very short. 0.82. What is the ratio of the Emissions(kt) in Kyrgyz Republic in 1998 to that in 2004?
Offer a terse response. 1.02. What is the ratio of the Emissions(kt) of Bolivia in 1998 to that in 2005?
Offer a terse response. 0.95. What is the ratio of the Emissions(kt) of Congo (Republic) in 1998 to that in 2005?
Your answer should be compact. 0.63. What is the ratio of the Emissions(kt) in Grenada in 1998 to that in 2005?
Offer a very short reply. 0.81. What is the ratio of the Emissions(kt) in Kyrgyz Republic in 1998 to that in 2005?
Provide a short and direct response. 1.11. What is the ratio of the Emissions(kt) in Bolivia in 1999 to that in 2000?
Provide a short and direct response. 1.1. What is the ratio of the Emissions(kt) of Congo (Republic) in 1999 to that in 2000?
Your answer should be compact. 0.78. What is the ratio of the Emissions(kt) in Grenada in 1999 to that in 2000?
Give a very brief answer. 1.02. What is the ratio of the Emissions(kt) in Kyrgyz Republic in 1999 to that in 2000?
Offer a terse response. 1.01. What is the ratio of the Emissions(kt) of Bolivia in 1999 to that in 2001?
Ensure brevity in your answer.  1.14. What is the ratio of the Emissions(kt) in Congo (Republic) in 1999 to that in 2001?
Keep it short and to the point. 1.07. What is the ratio of the Emissions(kt) of Kyrgyz Republic in 1999 to that in 2001?
Provide a short and direct response. 1.21. What is the ratio of the Emissions(kt) of Bolivia in 1999 to that in 2002?
Keep it short and to the point. 1.18. What is the ratio of the Emissions(kt) in Congo (Republic) in 1999 to that in 2002?
Offer a terse response. 1.43. What is the ratio of the Emissions(kt) in Grenada in 1999 to that in 2002?
Your answer should be very brief. 0.95. What is the ratio of the Emissions(kt) in Kyrgyz Republic in 1999 to that in 2002?
Provide a short and direct response. 0.94. What is the ratio of the Emissions(kt) of Bolivia in 1999 to that in 2003?
Provide a short and direct response. 0.8. What is the ratio of the Emissions(kt) of Congo (Republic) in 1999 to that in 2003?
Ensure brevity in your answer.  0.9. What is the ratio of the Emissions(kt) in Grenada in 1999 to that in 2003?
Offer a terse response. 0.9. What is the ratio of the Emissions(kt) in Kyrgyz Republic in 1999 to that in 2003?
Give a very brief answer. 0.86. What is the ratio of the Emissions(kt) in Bolivia in 1999 to that in 2004?
Offer a very short reply. 0.86. What is the ratio of the Emissions(kt) of Congo (Republic) in 1999 to that in 2004?
Offer a terse response. 0.86. What is the ratio of the Emissions(kt) in Grenada in 1999 to that in 2004?
Your answer should be very brief. 0.95. What is the ratio of the Emissions(kt) of Kyrgyz Republic in 1999 to that in 2004?
Provide a succinct answer. 0.8. What is the ratio of the Emissions(kt) in Bolivia in 1999 to that in 2005?
Your answer should be very brief. 0.93. What is the ratio of the Emissions(kt) in Congo (Republic) in 1999 to that in 2005?
Your answer should be compact. 0.66. What is the ratio of the Emissions(kt) of Grenada in 1999 to that in 2005?
Your answer should be very brief. 0.9. What is the ratio of the Emissions(kt) in Kyrgyz Republic in 1999 to that in 2005?
Provide a succinct answer. 0.87. What is the ratio of the Emissions(kt) in Bolivia in 2000 to that in 2001?
Your response must be concise. 1.04. What is the ratio of the Emissions(kt) in Congo (Republic) in 2000 to that in 2001?
Give a very brief answer. 1.37. What is the ratio of the Emissions(kt) of Grenada in 2000 to that in 2001?
Your response must be concise. 0.98. What is the ratio of the Emissions(kt) in Kyrgyz Republic in 2000 to that in 2001?
Provide a short and direct response. 1.2. What is the ratio of the Emissions(kt) in Bolivia in 2000 to that in 2002?
Offer a terse response. 1.07. What is the ratio of the Emissions(kt) in Congo (Republic) in 2000 to that in 2002?
Your response must be concise. 1.82. What is the ratio of the Emissions(kt) of Grenada in 2000 to that in 2002?
Keep it short and to the point. 0.93. What is the ratio of the Emissions(kt) in Kyrgyz Republic in 2000 to that in 2002?
Offer a terse response. 0.93. What is the ratio of the Emissions(kt) in Bolivia in 2000 to that in 2003?
Make the answer very short. 0.72. What is the ratio of the Emissions(kt) of Congo (Republic) in 2000 to that in 2003?
Give a very brief answer. 1.14. What is the ratio of the Emissions(kt) of Grenada in 2000 to that in 2003?
Provide a short and direct response. 0.88. What is the ratio of the Emissions(kt) of Kyrgyz Republic in 2000 to that in 2003?
Your answer should be compact. 0.85. What is the ratio of the Emissions(kt) in Bolivia in 2000 to that in 2004?
Provide a short and direct response. 0.78. What is the ratio of the Emissions(kt) of Congo (Republic) in 2000 to that in 2004?
Your answer should be compact. 1.1. What is the ratio of the Emissions(kt) of Kyrgyz Republic in 2000 to that in 2004?
Give a very brief answer. 0.79. What is the ratio of the Emissions(kt) in Bolivia in 2000 to that in 2005?
Provide a succinct answer. 0.85. What is the ratio of the Emissions(kt) of Congo (Republic) in 2000 to that in 2005?
Provide a short and direct response. 0.85. What is the ratio of the Emissions(kt) in Grenada in 2000 to that in 2005?
Your answer should be very brief. 0.88. What is the ratio of the Emissions(kt) in Kyrgyz Republic in 2000 to that in 2005?
Keep it short and to the point. 0.86. What is the ratio of the Emissions(kt) of Bolivia in 2001 to that in 2002?
Keep it short and to the point. 1.03. What is the ratio of the Emissions(kt) in Congo (Republic) in 2001 to that in 2002?
Provide a short and direct response. 1.33. What is the ratio of the Emissions(kt) of Grenada in 2001 to that in 2002?
Offer a terse response. 0.95. What is the ratio of the Emissions(kt) in Kyrgyz Republic in 2001 to that in 2002?
Ensure brevity in your answer.  0.78. What is the ratio of the Emissions(kt) in Bolivia in 2001 to that in 2003?
Ensure brevity in your answer.  0.7. What is the ratio of the Emissions(kt) in Congo (Republic) in 2001 to that in 2003?
Your answer should be very brief. 0.84. What is the ratio of the Emissions(kt) of Grenada in 2001 to that in 2003?
Offer a very short reply. 0.9. What is the ratio of the Emissions(kt) of Kyrgyz Republic in 2001 to that in 2003?
Your answer should be compact. 0.71. What is the ratio of the Emissions(kt) in Bolivia in 2001 to that in 2004?
Provide a short and direct response. 0.75. What is the ratio of the Emissions(kt) of Congo (Republic) in 2001 to that in 2004?
Make the answer very short. 0.81. What is the ratio of the Emissions(kt) in Grenada in 2001 to that in 2004?
Give a very brief answer. 0.95. What is the ratio of the Emissions(kt) of Kyrgyz Republic in 2001 to that in 2004?
Ensure brevity in your answer.  0.66. What is the ratio of the Emissions(kt) of Bolivia in 2001 to that in 2005?
Provide a succinct answer. 0.81. What is the ratio of the Emissions(kt) in Congo (Republic) in 2001 to that in 2005?
Give a very brief answer. 0.62. What is the ratio of the Emissions(kt) of Grenada in 2001 to that in 2005?
Offer a terse response. 0.9. What is the ratio of the Emissions(kt) of Kyrgyz Republic in 2001 to that in 2005?
Provide a succinct answer. 0.72. What is the ratio of the Emissions(kt) of Bolivia in 2002 to that in 2003?
Keep it short and to the point. 0.68. What is the ratio of the Emissions(kt) of Congo (Republic) in 2002 to that in 2003?
Offer a very short reply. 0.63. What is the ratio of the Emissions(kt) in Grenada in 2002 to that in 2003?
Offer a terse response. 0.95. What is the ratio of the Emissions(kt) in Kyrgyz Republic in 2002 to that in 2003?
Provide a succinct answer. 0.91. What is the ratio of the Emissions(kt) of Bolivia in 2002 to that in 2004?
Your answer should be compact. 0.73. What is the ratio of the Emissions(kt) in Congo (Republic) in 2002 to that in 2004?
Ensure brevity in your answer.  0.61. What is the ratio of the Emissions(kt) in Grenada in 2002 to that in 2004?
Give a very brief answer. 1. What is the ratio of the Emissions(kt) in Kyrgyz Republic in 2002 to that in 2004?
Offer a terse response. 0.85. What is the ratio of the Emissions(kt) in Bolivia in 2002 to that in 2005?
Provide a short and direct response. 0.79. What is the ratio of the Emissions(kt) of Congo (Republic) in 2002 to that in 2005?
Keep it short and to the point. 0.46. What is the ratio of the Emissions(kt) in Grenada in 2002 to that in 2005?
Offer a very short reply. 0.95. What is the ratio of the Emissions(kt) in Kyrgyz Republic in 2002 to that in 2005?
Your response must be concise. 0.92. What is the ratio of the Emissions(kt) of Bolivia in 2003 to that in 2004?
Ensure brevity in your answer.  1.08. What is the ratio of the Emissions(kt) of Congo (Republic) in 2003 to that in 2004?
Your response must be concise. 0.97. What is the ratio of the Emissions(kt) of Grenada in 2003 to that in 2004?
Give a very brief answer. 1.05. What is the ratio of the Emissions(kt) in Kyrgyz Republic in 2003 to that in 2004?
Give a very brief answer. 0.93. What is the ratio of the Emissions(kt) in Bolivia in 2003 to that in 2005?
Your answer should be compact. 1.17. What is the ratio of the Emissions(kt) in Congo (Republic) in 2003 to that in 2005?
Provide a short and direct response. 0.74. What is the ratio of the Emissions(kt) of Grenada in 2003 to that in 2005?
Ensure brevity in your answer.  1. What is the ratio of the Emissions(kt) of Kyrgyz Republic in 2003 to that in 2005?
Offer a terse response. 1.02. What is the ratio of the Emissions(kt) in Bolivia in 2004 to that in 2005?
Your answer should be compact. 1.08. What is the ratio of the Emissions(kt) of Congo (Republic) in 2004 to that in 2005?
Ensure brevity in your answer.  0.77. What is the ratio of the Emissions(kt) of Grenada in 2004 to that in 2005?
Make the answer very short. 0.95. What is the ratio of the Emissions(kt) in Kyrgyz Republic in 2004 to that in 2005?
Provide a short and direct response. 1.09. What is the difference between the highest and the second highest Emissions(kt) in Bolivia?
Provide a succinct answer. 1045.1. What is the difference between the highest and the second highest Emissions(kt) in Congo (Republic)?
Your response must be concise. 190.68. What is the difference between the highest and the second highest Emissions(kt) of Kyrgyz Republic?
Ensure brevity in your answer.  99.01. What is the difference between the highest and the lowest Emissions(kt) of Bolivia?
Your answer should be very brief. 4561.75. What is the difference between the highest and the lowest Emissions(kt) of Congo (Republic)?
Make the answer very short. 663.73. What is the difference between the highest and the lowest Emissions(kt) in Grenada?
Your response must be concise. 40.34. What is the difference between the highest and the lowest Emissions(kt) of Kyrgyz Republic?
Ensure brevity in your answer.  2042.52. 